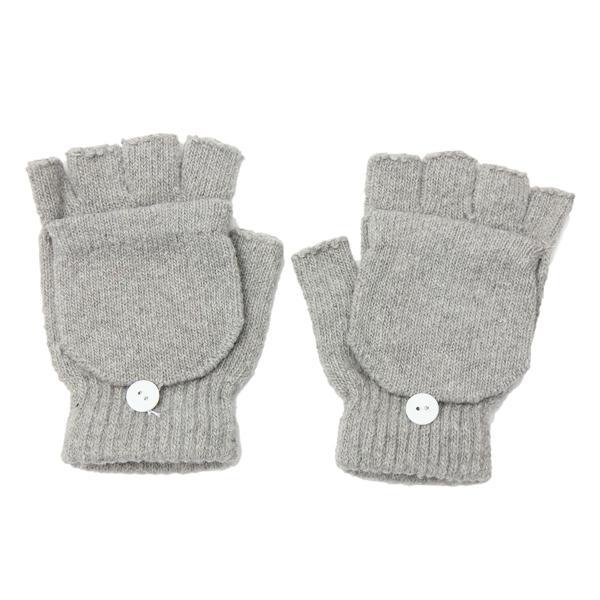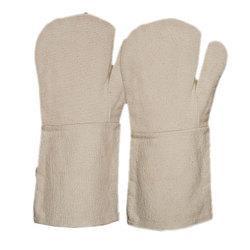The first image is the image on the left, the second image is the image on the right. For the images shown, is this caption "Both gloves have detachable fingers" true? Answer yes or no. No. The first image is the image on the left, the second image is the image on the right. Considering the images on both sides, is "the gloves on the right don't have cut off fingers" valid? Answer yes or no. Yes. 